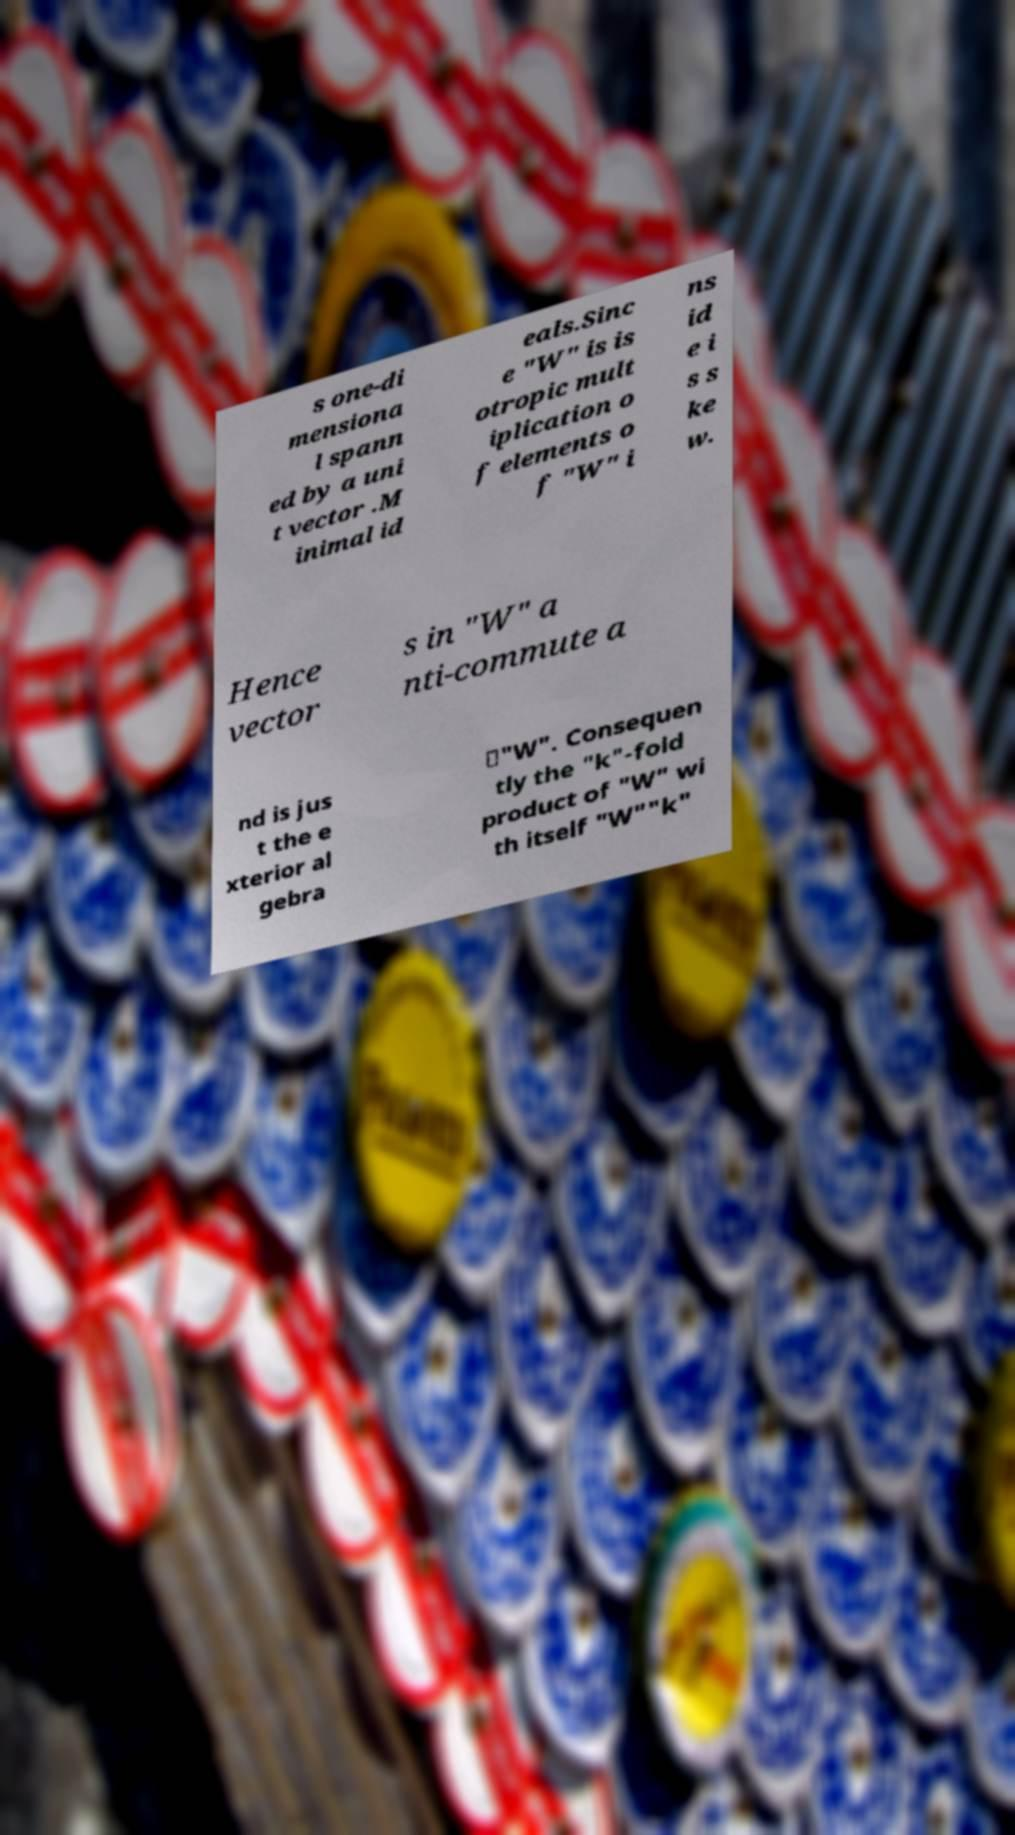Please identify and transcribe the text found in this image. s one-di mensiona l spann ed by a uni t vector .M inimal id eals.Sinc e "W" is is otropic mult iplication o f elements o f "W" i ns id e i s s ke w. Hence vector s in "W" a nti-commute a nd is jus t the e xterior al gebra ∗"W". Consequen tly the "k"-fold product of "W" wi th itself "W""k" 